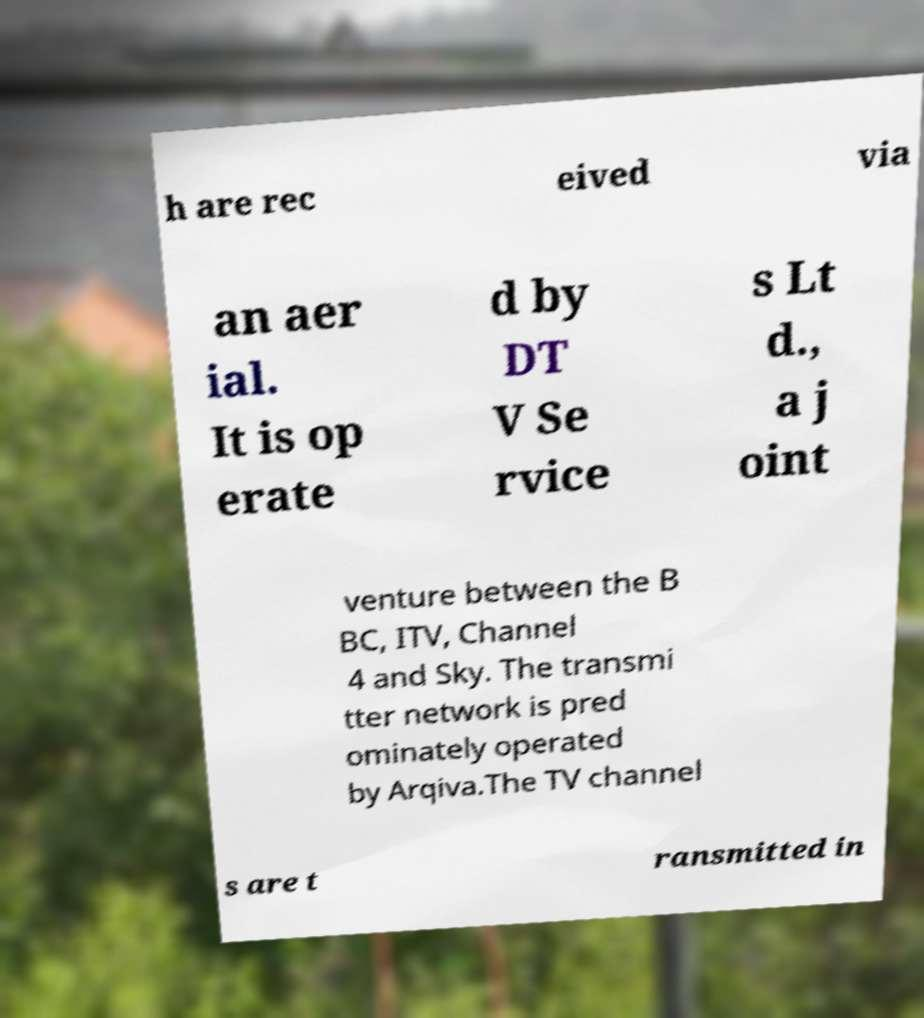Could you assist in decoding the text presented in this image and type it out clearly? h are rec eived via an aer ial. It is op erate d by DT V Se rvice s Lt d., a j oint venture between the B BC, ITV, Channel 4 and Sky. The transmi tter network is pred ominately operated by Arqiva.The TV channel s are t ransmitted in 